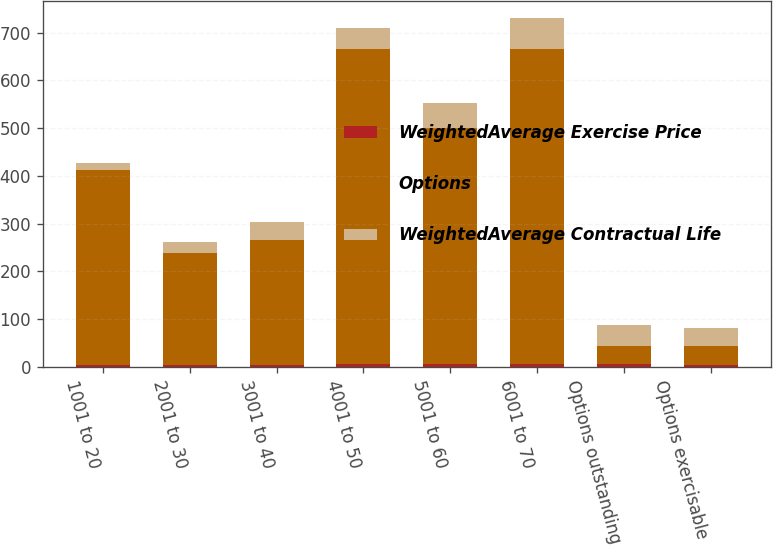<chart> <loc_0><loc_0><loc_500><loc_500><stacked_bar_chart><ecel><fcel>1001 to 20<fcel>2001 to 30<fcel>3001 to 40<fcel>4001 to 50<fcel>5001 to 60<fcel>6001 to 70<fcel>Options outstanding<fcel>Options exercisable<nl><fcel>WeightedAverage Exercise Price<fcel>4<fcel>5.1<fcel>3.1<fcel>6.6<fcel>6.7<fcel>5.8<fcel>5.6<fcel>4.4<nl><fcel>Options<fcel>409<fcel>233<fcel>262<fcel>659<fcel>494<fcel>660<fcel>38.5<fcel>38.5<nl><fcel>WeightedAverage Contractual Life<fcel>13<fcel>23<fcel>39<fcel>44<fcel>52<fcel>64<fcel>43<fcel>38<nl></chart> 